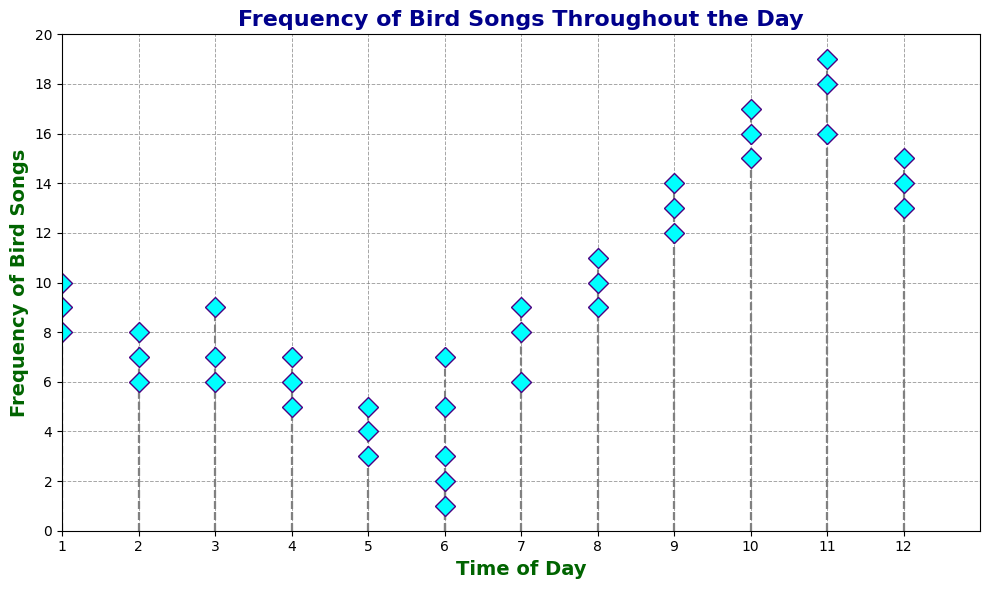How many bird songs were recorded at 8 AM? Refer to the stem plot where Time of Day is 8 AM, the recorded frequencies are 9, 10, and 11. Sum these values: 9 + 10 + 11 = 30.
Answer: 30 During which time of the day was the highest frequency of bird songs recorded? Identify the highest point on the stem plot. The maximum frequency of bird songs is 19, which occurs at 11 AM.
Answer: 11 AM What's the average frequency of bird songs recorded between 12 PM and 2 PM? The frequencies recorded are: 14, 15, 13 (12 PM), 10, 9, 8 (1 PM), and 7, 6, 8 (2 PM). Sum these values: 14 + 15 + 13 + 10 + 9 + 8 + 7 + 6 + 8 = 90. The number of data points is 9. Average: 90 / 9 = 10.
Answer: 10 Which time of the day had a higher total frequency of bird songs, 6 AM or 3 PM? Sum the values for 6 AM: 5, 7; 1, 2 and 3. Total: 5+7+1+2+3=18. Sum the values for 3 PM: 9, 7, and 6. Total: 9+7+6=22.
Answer: 3 PM How does the frequency of bird songs at 10 AM compare visually to that at 4 PM? Refer to the stem plot for heights of markers at 10 AM and 4 PM. At 10 AM, frequencies are 16, 15, and 17, with markers higher on the plot compared to lower markers at 4 PM for frequencies of 5, 6, and 7.
Answer: 10 AM higher What's the median frequency of bird songs recorded at 9 AM? The frequencies at 9 AM are 13, 12, and 14. Arrange in ascending order: 12, 13, 14. The middle value is the median: 13.
Answer: 13 Compare the sums of the frequencies recorded in the morning (6 AM to 12 PM) and the afternoon (1 PM to 6 PM). Which one had a higher total frequency? Morning frequencies: 5+7+8+6+9+11+10+9+13+12+14+16+15+17+18+16+19+14+15+13 = 238. Afternoon frequencies: 10+9+8+7+6+8+9+7+6+5+6+7+4+3+5+2+1+3 = 102. Morning is higher.
Answer: Morning How does the frequency at 5 PM look in comparison to 11 AM? Observing the stems, the frequencies at 5 PM are lower (4, 3, and 5) compared to the higher frequencies at 11 AM (18, 16, 19).
Answer: 11 AM higher What is the total frequency of bird songs from 6 AM to 10 AM? Sum the frequencies from 6 AM to 10 AM: 5+7+8+6+9+11+10+9+13+12+14+16+15+17 = 142.
Answer: 142 